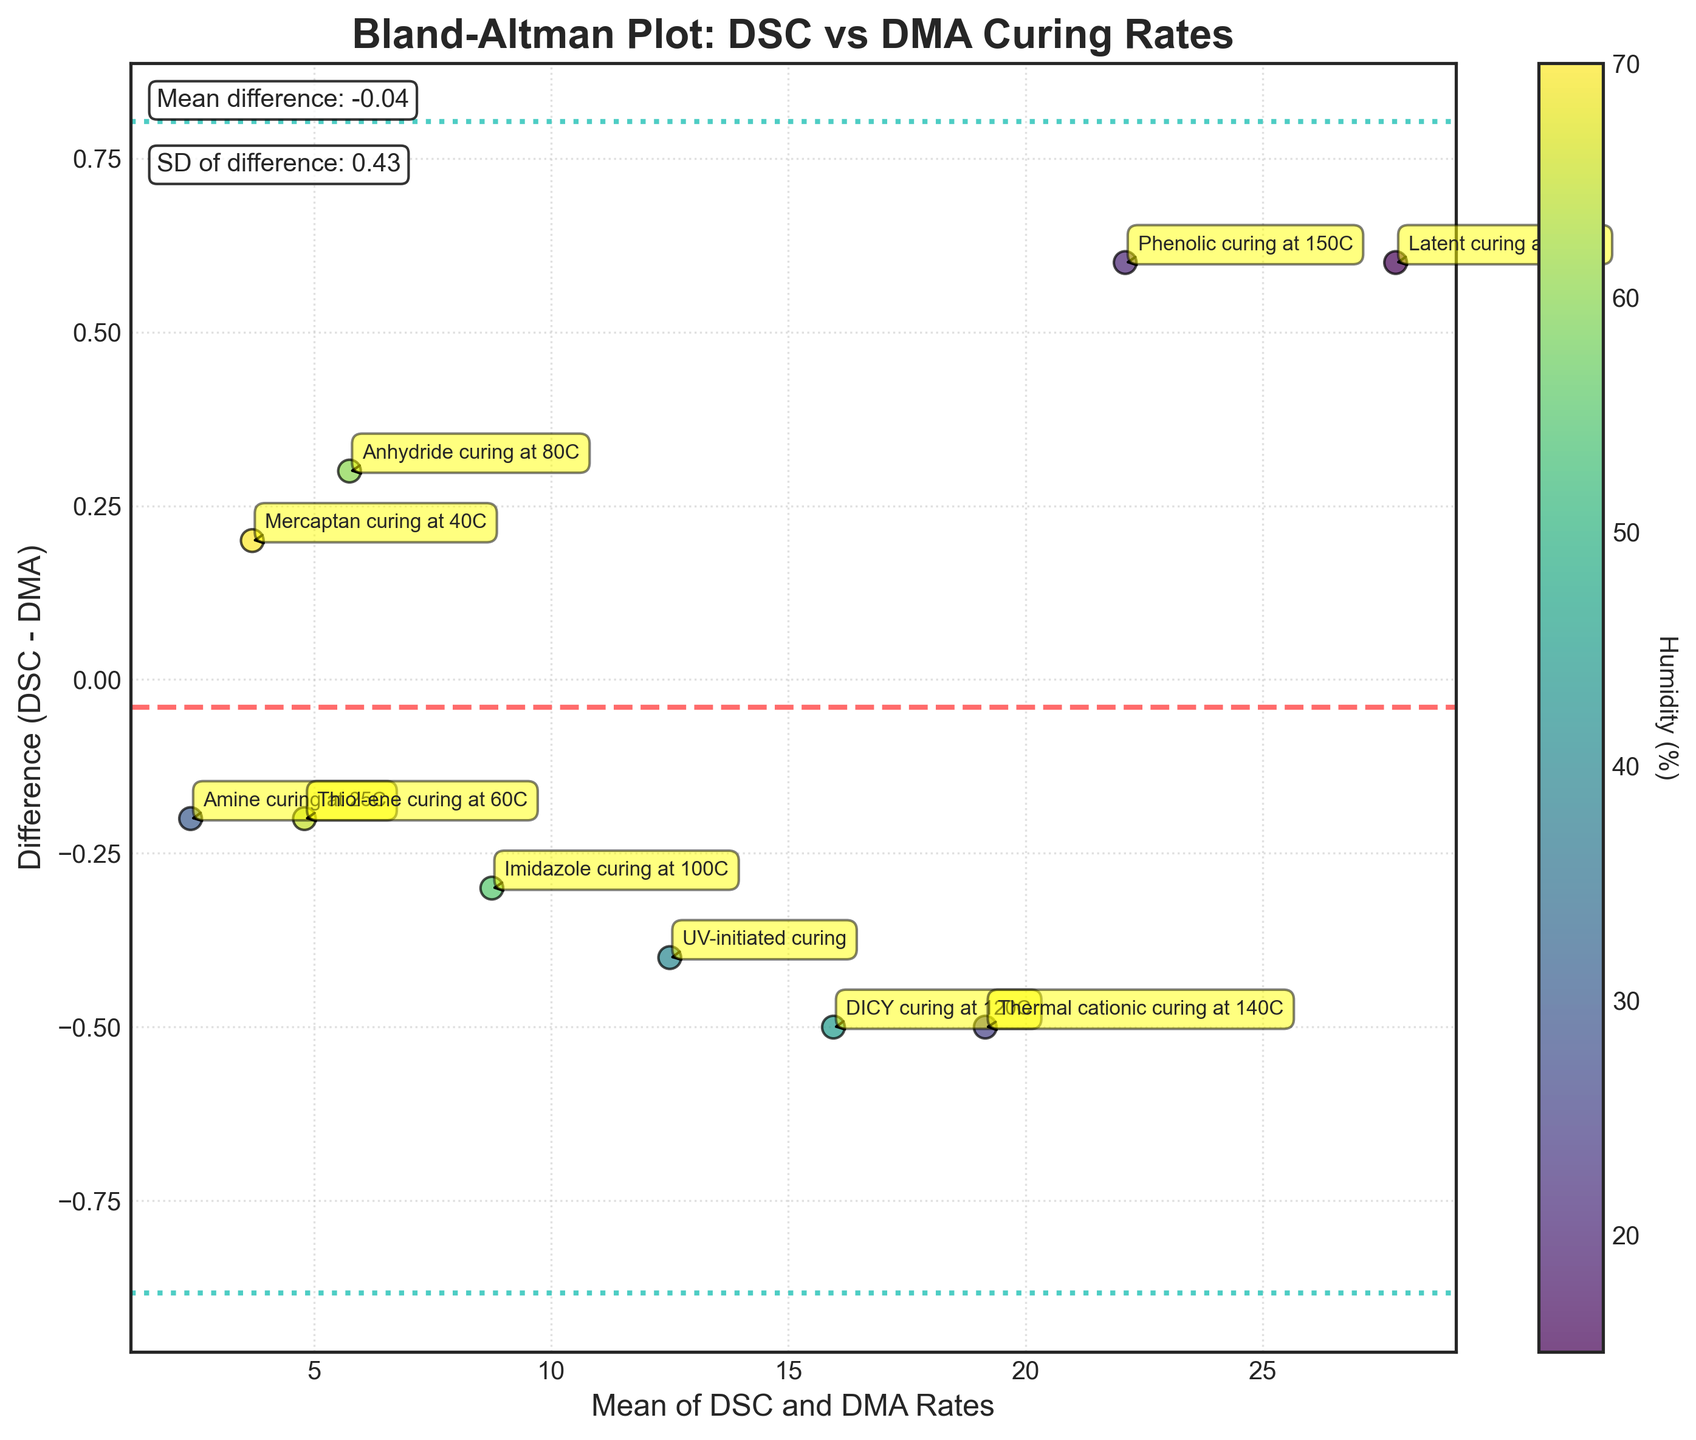How many data points are there? Count the number of data points presented in the scatter plot. Each data point corresponds to a curing method, and there are 10 different methods listed.
Answer: 10 What's the title of the plot? Read the title positioned at the top of the graph. The title gives a clear description of what the plot is about.
Answer: Bland-Altman Plot: DSC vs DMA Curing Rates Which curing method has the highest mean rate? Locate the data points and annotations. The latent curing method at 180C appears at the highest point on the x-axis which indicates the highest mean value.
Answer: Latent curing at 180C Is the mean difference between DSC and DMA rates positive or negative? The mean difference line is located at a positive y-value. This indicates that the DSC rates are typically higher than the DMA rates.
Answer: Positive What is the standard deviation of the differences? Read the text annotation in the plot. It states the standard deviation value for the differences between DSC and DMA rates.
Answer: 0.57 Compare the difference for Amine curing at 25C and Mercaptan curing at 40C. Which one is greater? Locate the positions and annotations for both methods. The Amine curing at 25C has a greater positive difference (2.3 - 2.5 = -0.2) than Mercaptan curing at 40C (3.8 - 3.6 = 0.2).
Answer: Mercaptan curing at 40C Which method shows the smallest difference between DSC and DMA values? Identify the point closest to the zero line on the y-axis. Anhydride curing at 80C has the smallest difference.
Answer: Anhydride curing at 80C Where is the highest humidity observed in the plot? Observe the color bar and corresponding data points. The Mercaptan curing at 40C data point is the darkest, indicating the highest humidity value of 70%.
Answer: Mercaptan curing at 40C What's the range of differences covered within the 95% confidence interval? The range is from the lower confidence limit to the upper confidence limit. This is calculated as (mean difference - 1.96 * sd_diff) to (mean difference + 1.96 * sd_diff). From the annotations, the values are (0.57 - 1.96 * 0.57) to (0.57 + 1.96 * 0.57).
Answer: -0.56 to 1.70 What is the relationship shown by a positive mean difference in a Bland-Altman plot? In a Bland-Altman plot, a positive mean difference indicates that the values from one method (DSC) tend to be systematically higher than the values from the other method (DMA). This can show a bias or systematic error between the two methods.
Answer: DSC rates are systematically higher 